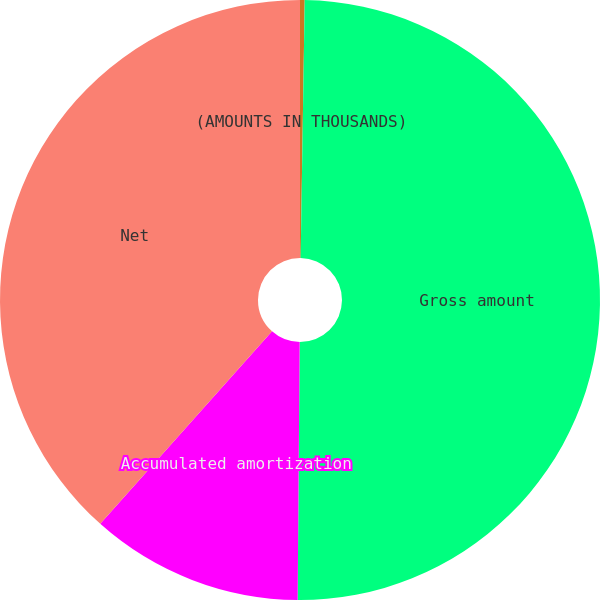Convert chart. <chart><loc_0><loc_0><loc_500><loc_500><pie_chart><fcel>(AMOUNTS IN THOUSANDS)<fcel>Gross amount<fcel>Accumulated amortization<fcel>Net<nl><fcel>0.25%<fcel>49.87%<fcel>11.47%<fcel>38.4%<nl></chart> 